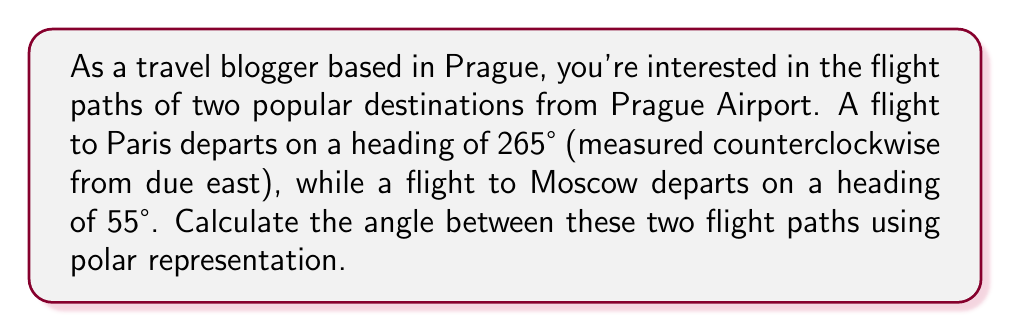Provide a solution to this math problem. To solve this problem, we need to use polar coordinates and understand how angles are measured in this system. In polar coordinates, angles are typically measured counterclockwise from the positive x-axis (which represents due east in this case).

Let's approach this step-by-step:

1) First, we need to convert the given headings to polar angles:
   - Paris flight: 265° (already measured counterclockwise from due east)
   - Moscow flight: 55° (already measured counterclockwise from due east)

2) To find the angle between these two flight paths, we need to subtract the smaller angle from the larger angle:

   $$\theta = 265° - 55° = 210°$$

3) However, we need to consider whether this is the smaller angle between the two paths. In polar coordinates, the smaller angle is always ≤ 180°. If our result is > 180°, we need to subtract it from 360°.

4) Since 210° > 180°, we calculate:

   $$360° - 210° = 150°$$

This gives us the smaller angle between the two flight paths.

[asy]
import geometry;

size(200);
draw(circle((0,0),1));
draw((-1.2,0)--(1.2,0),Arrow);
draw((0,-1.2)--(0,1.2),Arrow);

real deg = pi/180;
draw((0,0)--(cos(265*deg),sin(265*deg)),red,Arrow);
draw((0,0)--(cos(55*deg),sin(55*deg)),blue,Arrow);

label("East", (1.3,0), E);
label("North", (0,1.3), N);
label("265°", (0.3,-0.4), SW);
label("55°", (0.4,0.4), NE);
label("150°", (-0.2,0.1), SW);

dot((0,0));
[/asy]

The diagram above illustrates the flight paths and the angle between them in polar coordinates.
Answer: The angle between the two flight paths is 150°. 